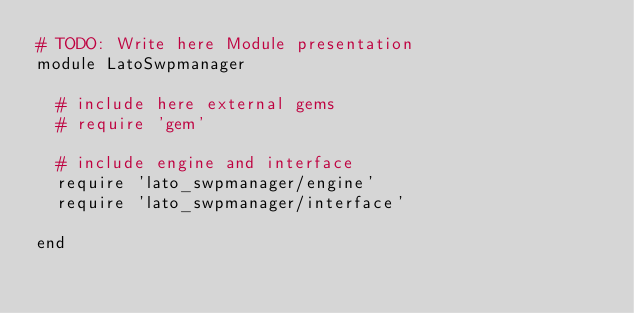Convert code to text. <code><loc_0><loc_0><loc_500><loc_500><_Ruby_># TODO: Write here Module presentation
module LatoSwpmanager

  # include here external gems
  # require 'gem'

  # include engine and interface
  require 'lato_swpmanager/engine'
  require 'lato_swpmanager/interface'

end
</code> 